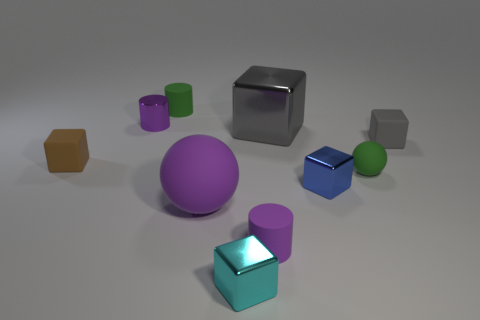There is a small green ball; what number of cyan metallic cubes are behind it?
Your answer should be very brief. 0. Are there more metallic things than brown matte blocks?
Keep it short and to the point. Yes. The rubber object that is the same color as the large ball is what size?
Provide a succinct answer. Small. How big is the purple thing that is both on the left side of the small purple rubber cylinder and in front of the tiny brown object?
Ensure brevity in your answer.  Large. What material is the purple sphere left of the small rubber cylinder that is in front of the gray cube right of the gray metal cube?
Keep it short and to the point. Rubber. What material is the small thing that is the same color as the tiny sphere?
Offer a very short reply. Rubber. There is a big thing that is in front of the brown matte object; is its color the same as the matte thing behind the big gray metallic cube?
Make the answer very short. No. The small metal object that is behind the tiny thing that is right of the green object on the right side of the cyan block is what shape?
Offer a very short reply. Cylinder. The small rubber thing that is both right of the big rubber ball and to the left of the small blue cube has what shape?
Your answer should be very brief. Cylinder. What number of big gray metallic objects are behind the big shiny block that is in front of the small green object that is on the left side of the big metal thing?
Offer a terse response. 0. 